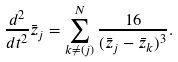<formula> <loc_0><loc_0><loc_500><loc_500>\frac { d ^ { 2 } } { d t ^ { 2 } } \bar { z } _ { j } = \sum _ { k \neq ( j ) } ^ { N } \frac { 1 6 } { ( \bar { z } _ { j } - \bar { z } _ { k } ) ^ { 3 } } .</formula> 